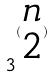<formula> <loc_0><loc_0><loc_500><loc_500>3 ^ { ( \begin{matrix} n \\ 2 \end{matrix} ) }</formula> 